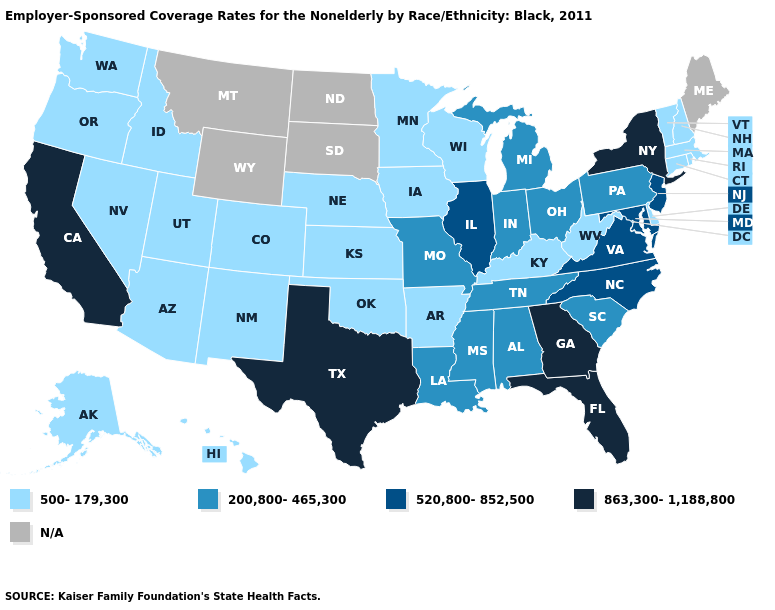Does Vermont have the lowest value in the Northeast?
Answer briefly. Yes. What is the value of Hawaii?
Keep it brief. 500-179,300. What is the value of California?
Write a very short answer. 863,300-1,188,800. How many symbols are there in the legend?
Be succinct. 5. How many symbols are there in the legend?
Be succinct. 5. What is the highest value in states that border Utah?
Answer briefly. 500-179,300. What is the lowest value in states that border Arkansas?
Concise answer only. 500-179,300. What is the value of Indiana?
Write a very short answer. 200,800-465,300. Name the states that have a value in the range 520,800-852,500?
Concise answer only. Illinois, Maryland, New Jersey, North Carolina, Virginia. Name the states that have a value in the range 200,800-465,300?
Write a very short answer. Alabama, Indiana, Louisiana, Michigan, Mississippi, Missouri, Ohio, Pennsylvania, South Carolina, Tennessee. Name the states that have a value in the range N/A?
Concise answer only. Maine, Montana, North Dakota, South Dakota, Wyoming. What is the lowest value in the USA?
Be succinct. 500-179,300. What is the value of New York?
Be succinct. 863,300-1,188,800. Among the states that border Wisconsin , which have the highest value?
Short answer required. Illinois. 